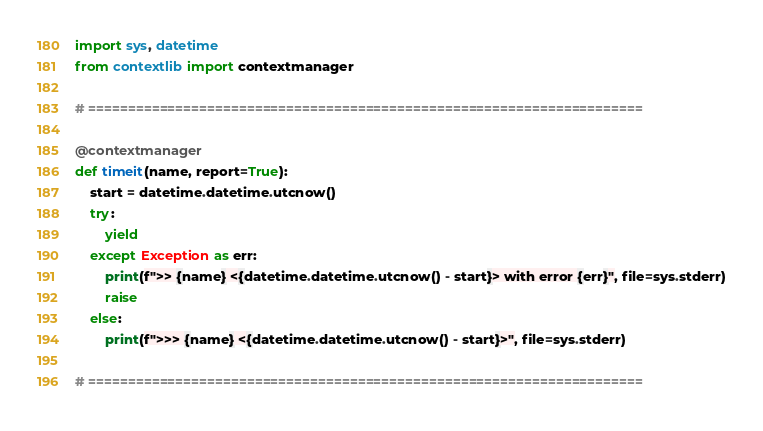Convert code to text. <code><loc_0><loc_0><loc_500><loc_500><_Python_>import sys, datetime
from contextlib import contextmanager

# ======================================================================

@contextmanager
def timeit(name, report=True):
    start = datetime.datetime.utcnow()
    try:
        yield
    except Exception as err:
        print(f">> {name} <{datetime.datetime.utcnow() - start}> with error {err}", file=sys.stderr)
        raise
    else:
        print(f">>> {name} <{datetime.datetime.utcnow() - start}>", file=sys.stderr)

# ======================================================================
</code> 